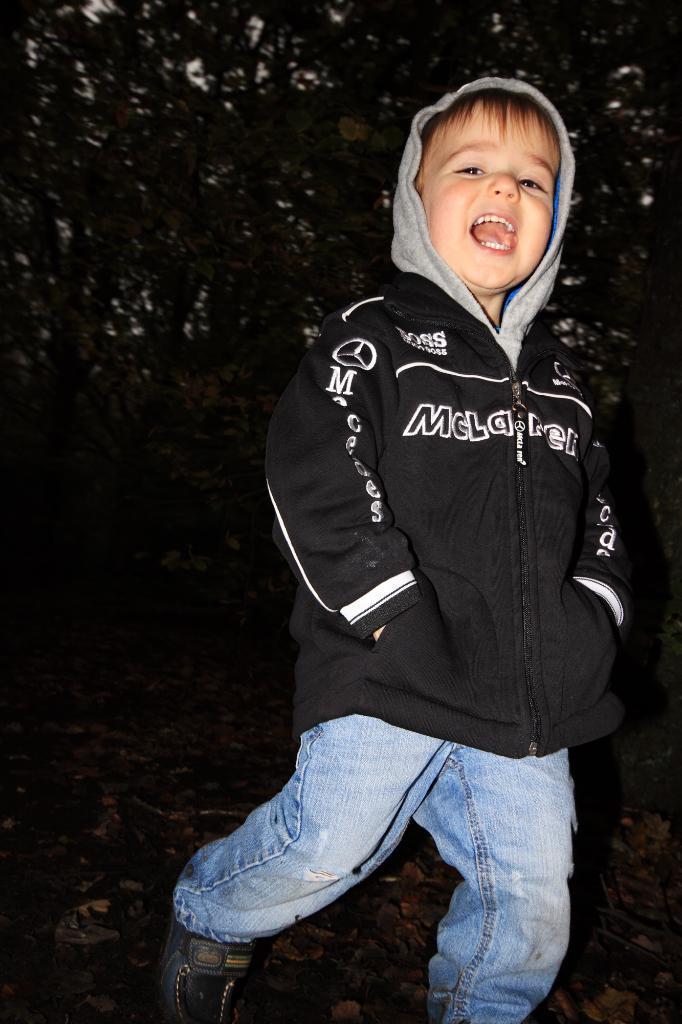Could you give a brief overview of what you see in this image? In this image in the foreground there is one boy who is screaming, and in the background there are trees. 